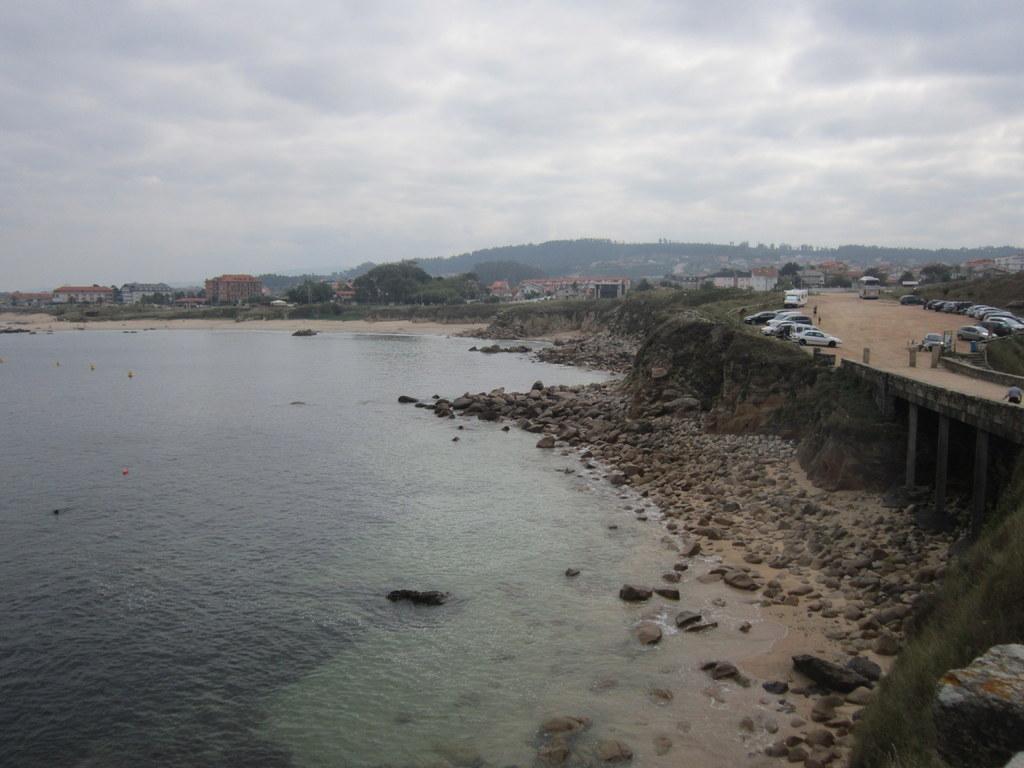Can you describe this image briefly? In this image I can see many vehicles on the bridge. To the side of the bridge I can see many stones and water. In the background I can see many trees, houses, mountains, clouds and the sky. 